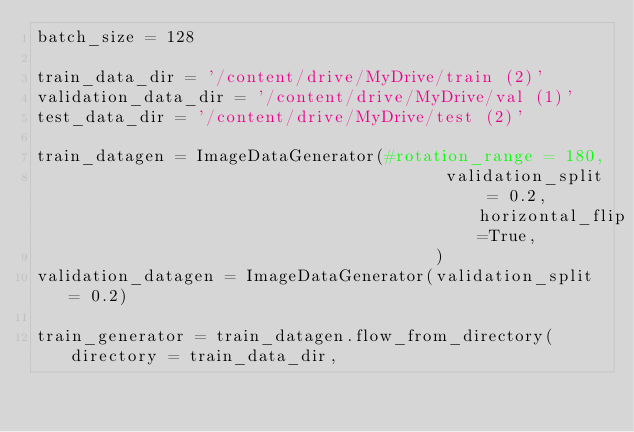<code> <loc_0><loc_0><loc_500><loc_500><_Python_>batch_size = 128

train_data_dir = '/content/drive/MyDrive/train (2)'
validation_data_dir = '/content/drive/MyDrive/val (1)'
test_data_dir = '/content/drive/MyDrive/test (2)'

train_datagen = ImageDataGenerator(#rotation_range = 180,
                                         validation_split = 0.2, horizontal_flip=True,
                                        )
validation_datagen = ImageDataGenerator(validation_split = 0.2)

train_generator = train_datagen.flow_from_directory(directory = train_data_dir,</code> 